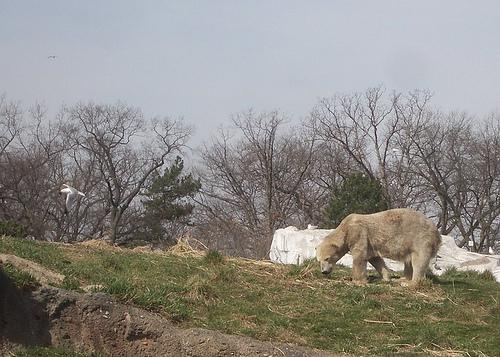Question: who is in the picture?
Choices:
A. Penguins.
B. Fish.
C. Polar bear.
D. Koala bears.
Answer with the letter. Answer: C Question: when is this picture taken?
Choices:
A. Summer.
B. Spring.
C. Winter.
D. Fall.
Answer with the letter. Answer: C Question: what is on the ground?
Choices:
A. Gravel.
B. Sand.
C. Hay and grass.
D. Snow.
Answer with the letter. Answer: C Question: what is in the front of the picture?
Choices:
A. Grass and flowers.
B. Rocks and dirt.
C. Sand and reeds.
D. Bushes and dirt.
Answer with the letter. Answer: B 